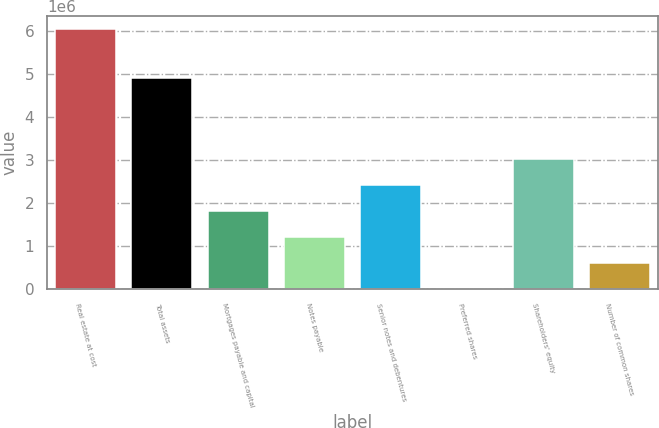Convert chart. <chart><loc_0><loc_0><loc_500><loc_500><bar_chart><fcel>Real estate at cost<fcel>Total assets<fcel>Mortgages payable and capital<fcel>Notes payable<fcel>Senior notes and debentures<fcel>Preferred shares<fcel>Shareholders' equity<fcel>Number of common shares<nl><fcel>6.06441e+06<fcel>4.91171e+06<fcel>1.82632e+06<fcel>1.22088e+06<fcel>2.43176e+06<fcel>9997<fcel>3.0372e+06<fcel>615438<nl></chart> 